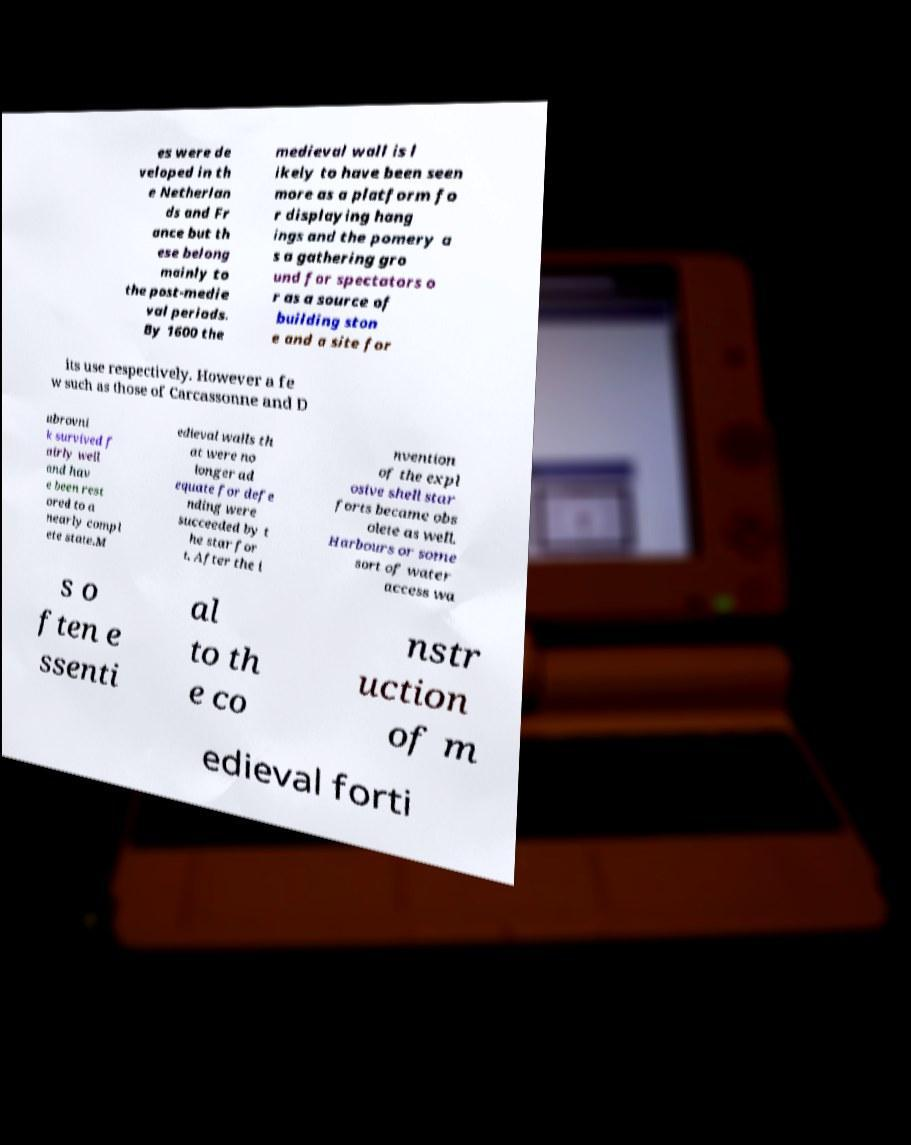I need the written content from this picture converted into text. Can you do that? es were de veloped in th e Netherlan ds and Fr ance but th ese belong mainly to the post-medie val periods. By 1600 the medieval wall is l ikely to have been seen more as a platform fo r displaying hang ings and the pomery a s a gathering gro und for spectators o r as a source of building ston e and a site for its use respectively. However a fe w such as those of Carcassonne and D ubrovni k survived f airly well and hav e been rest ored to a nearly compl ete state.M edieval walls th at were no longer ad equate for defe nding were succeeded by t he star for t. After the i nvention of the expl osive shell star forts became obs olete as well. Harbours or some sort of water access wa s o ften e ssenti al to th e co nstr uction of m edieval forti 